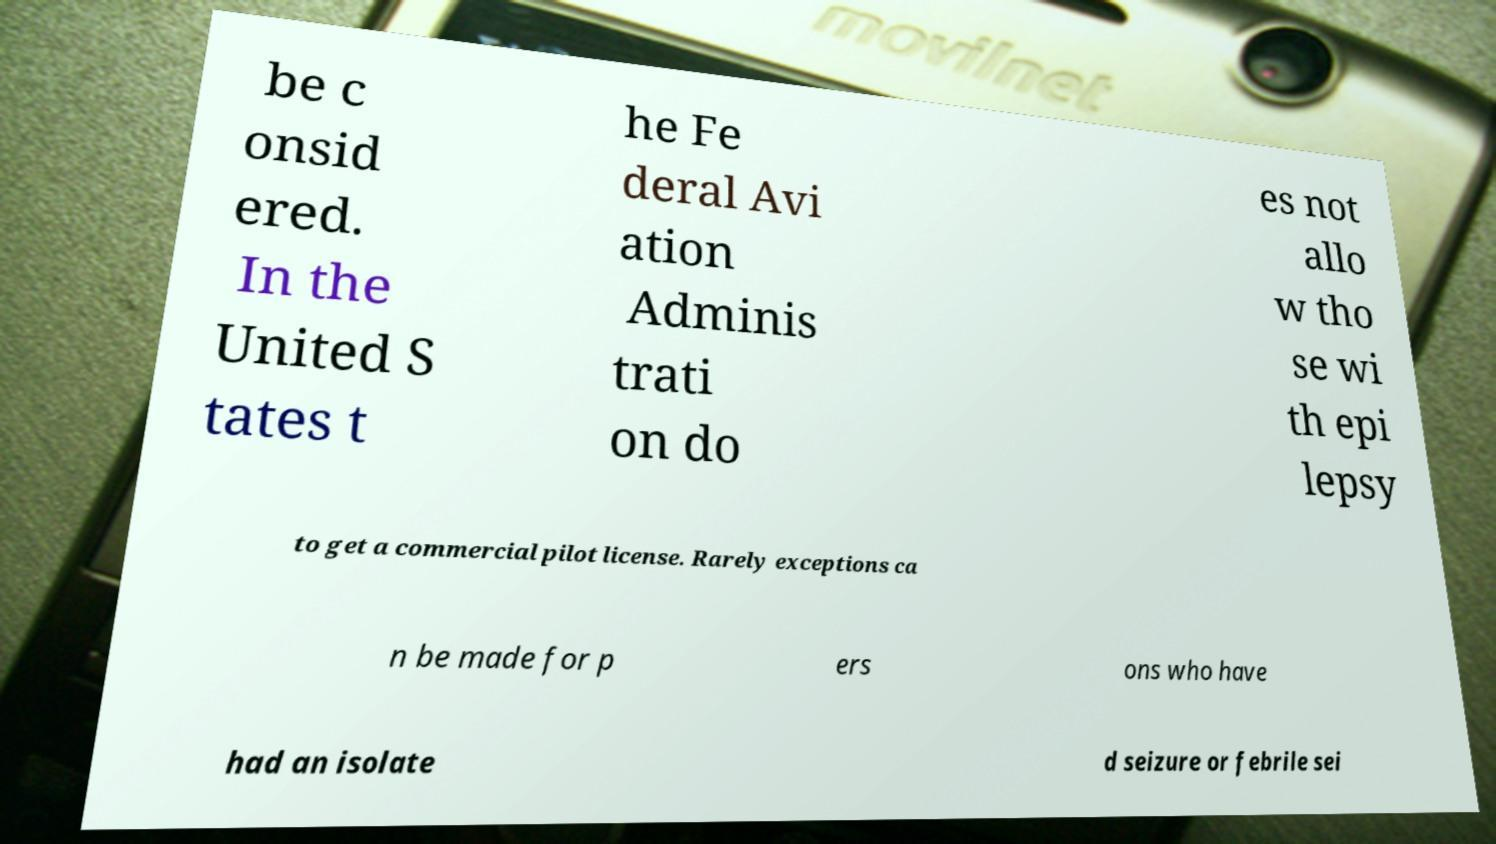Please identify and transcribe the text found in this image. be c onsid ered. In the United S tates t he Fe deral Avi ation Adminis trati on do es not allo w tho se wi th epi lepsy to get a commercial pilot license. Rarely exceptions ca n be made for p ers ons who have had an isolate d seizure or febrile sei 